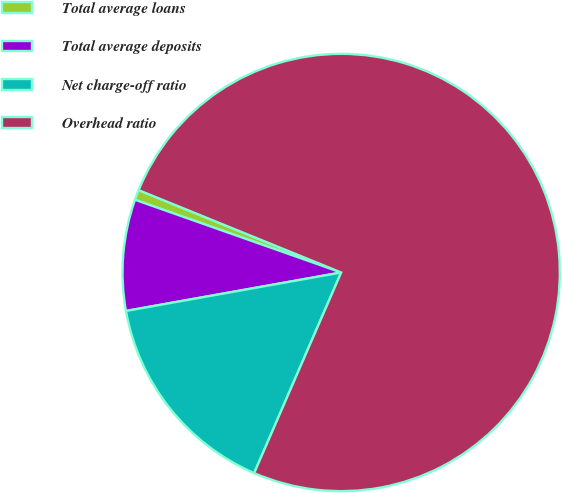<chart> <loc_0><loc_0><loc_500><loc_500><pie_chart><fcel>Total average loans<fcel>Total average deposits<fcel>Net charge-off ratio<fcel>Overhead ratio<nl><fcel>0.75%<fcel>8.21%<fcel>15.67%<fcel>75.36%<nl></chart> 